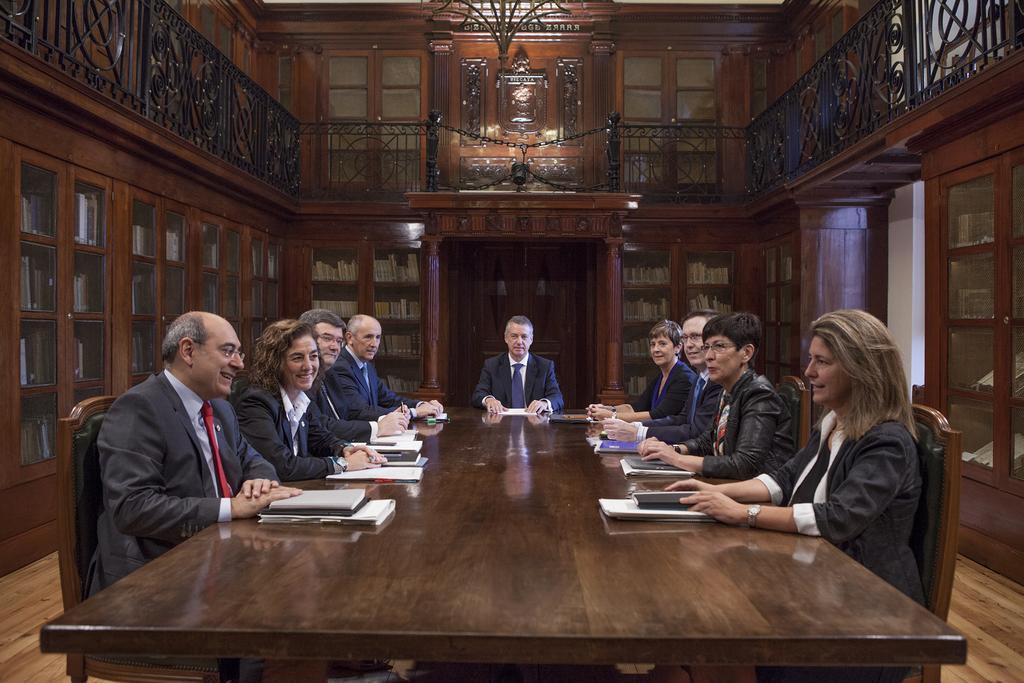Please provide a concise description of this image. In this image it seems like there are group of people who are sitting around the table,on the table there are books,files,papers. At the background there is door and cupboard in which there are books inside it. On the top there is iron railing all over the hall. 